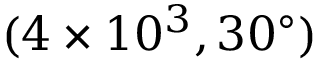Convert formula to latex. <formula><loc_0><loc_0><loc_500><loc_500>( 4 \times 1 0 ^ { 3 } , 3 0 ^ { \circ } )</formula> 